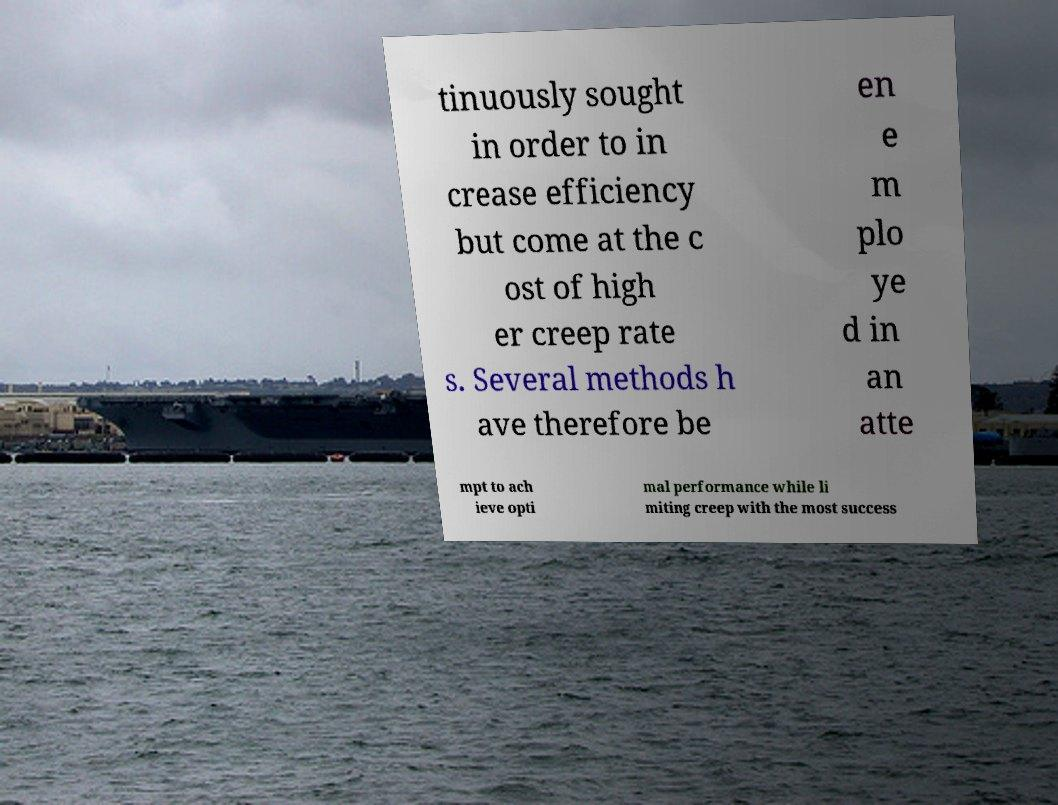Can you accurately transcribe the text from the provided image for me? tinuously sought in order to in crease efficiency but come at the c ost of high er creep rate s. Several methods h ave therefore be en e m plo ye d in an atte mpt to ach ieve opti mal performance while li miting creep with the most success 